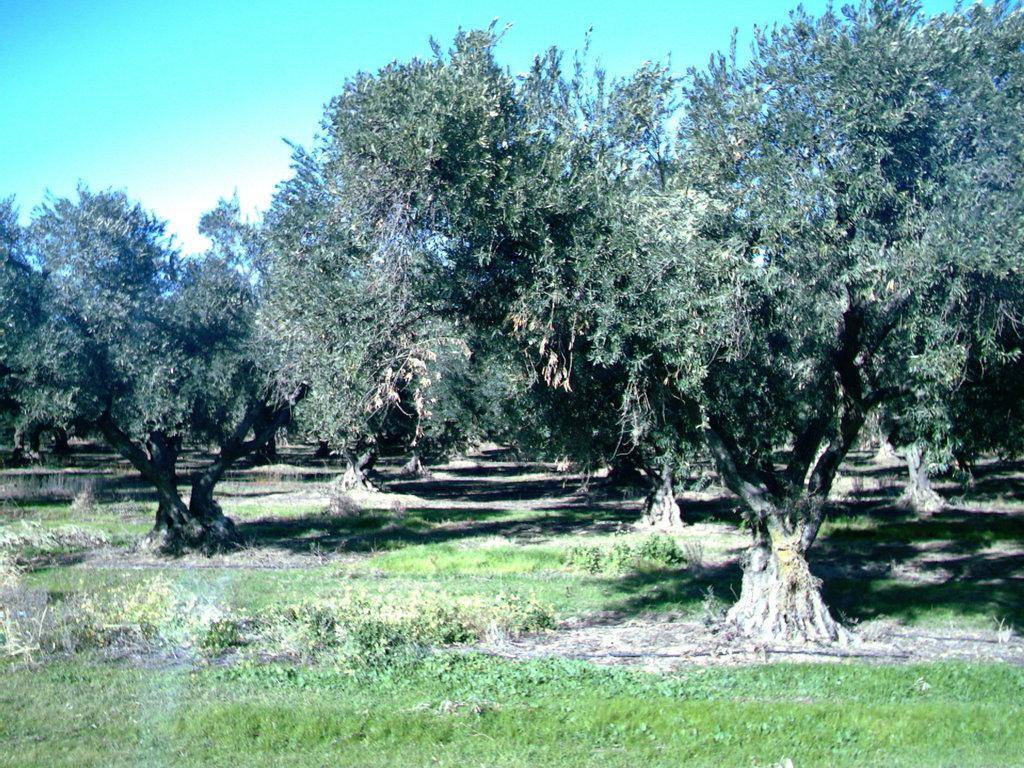What type of vegetation is present in the image? There are many trees in the image. What is the color of the grass on the ground in the image? The grass on the ground in the image is green. What part of the natural environment is visible in the image? The sky is visible at the top of the image. Can you see a drum being played in the image? There is no drum or any indication of a musical performance in the image. Is there a battle taking place in the image? There is no battle or any sign of conflict in the image. 